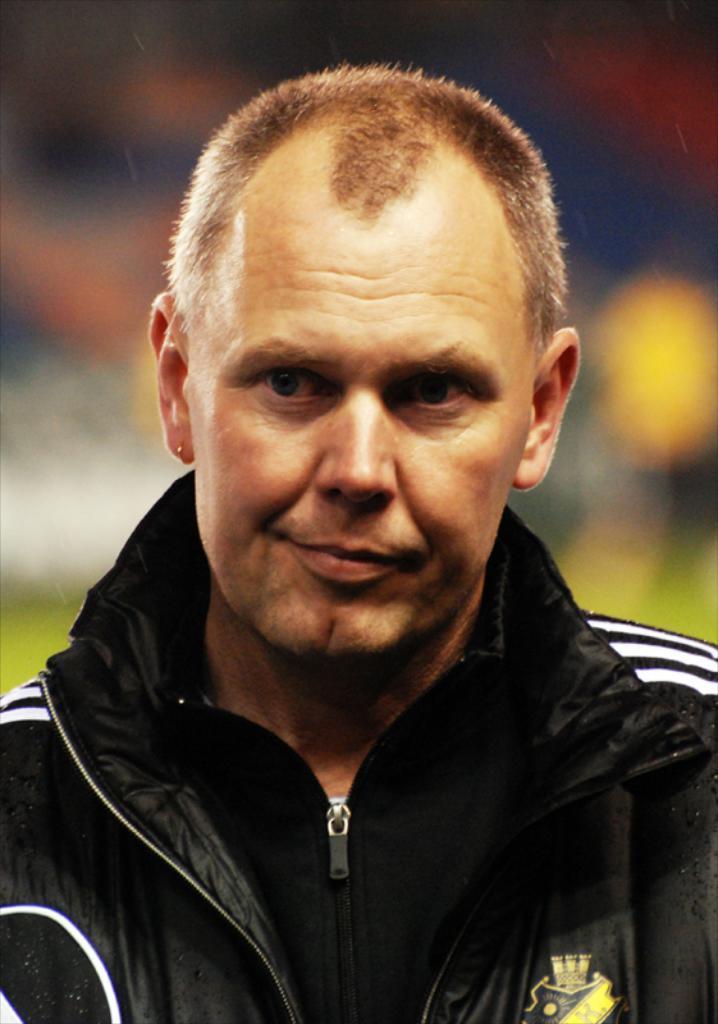How would you summarize this image in a sentence or two? In this image I can see the person is wearing black color dress. Background is blurred. 